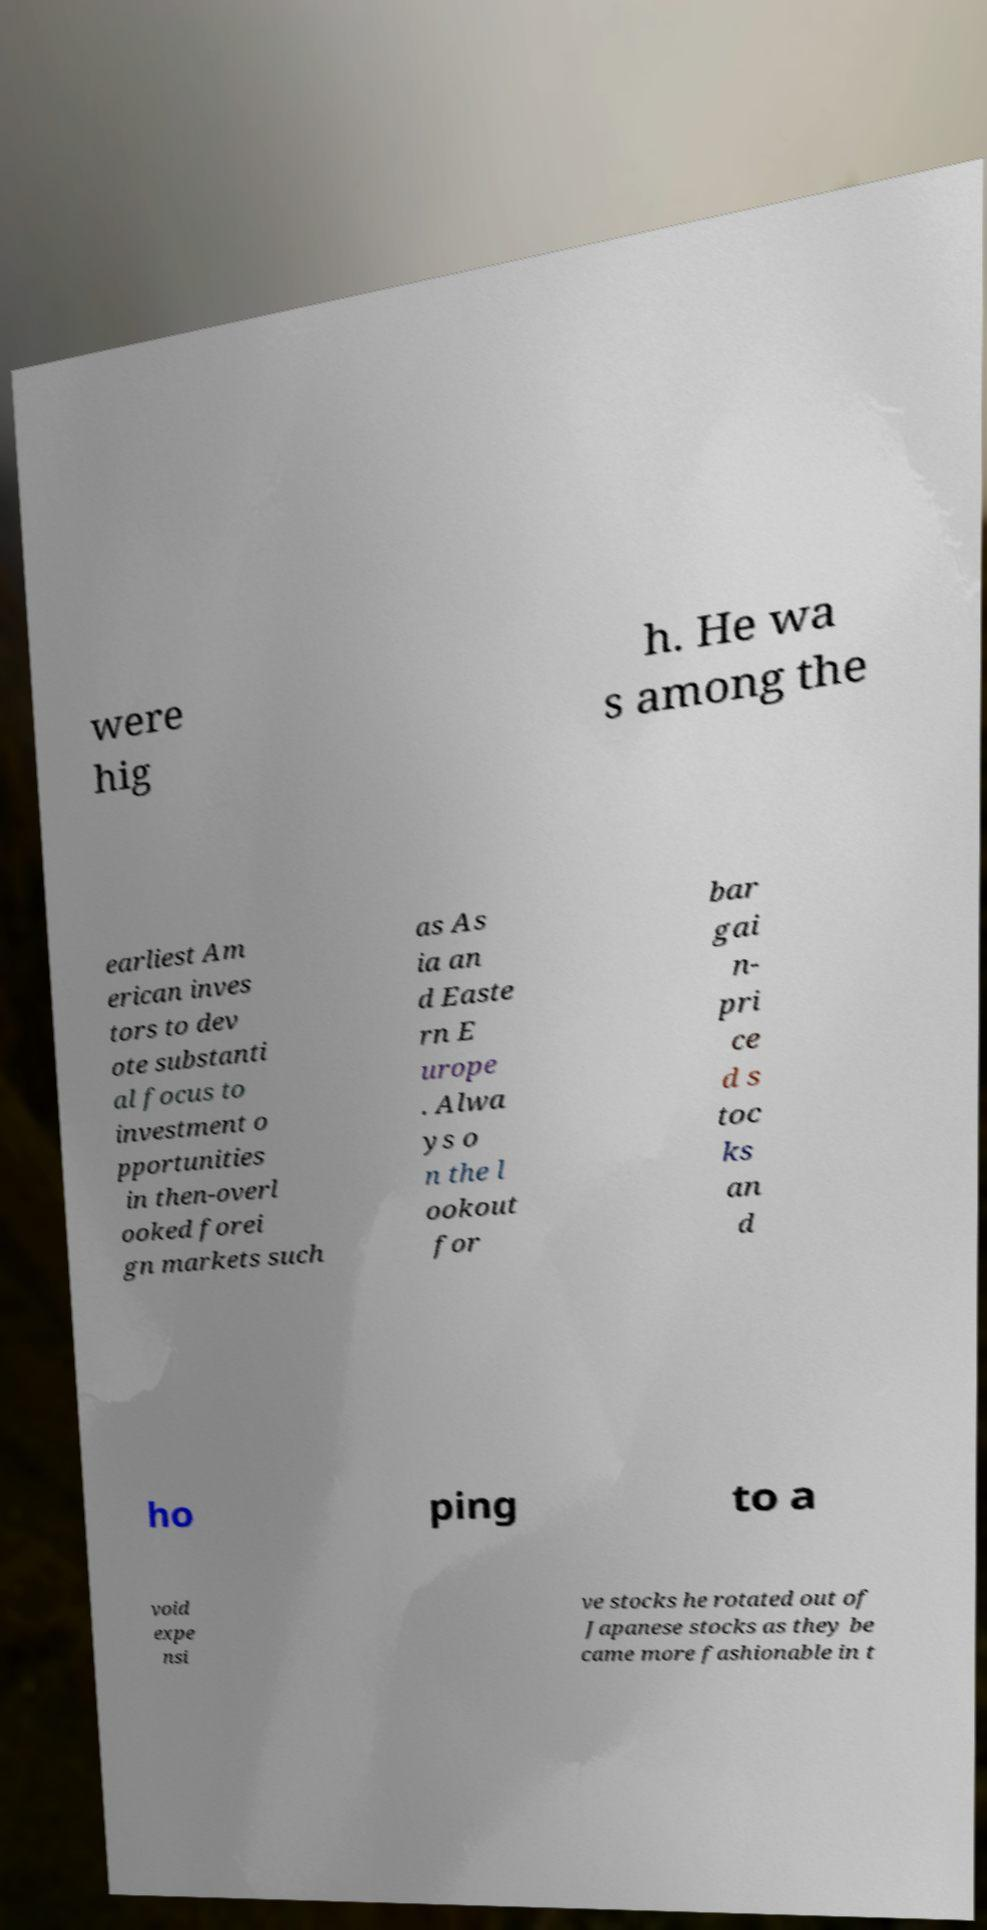Could you assist in decoding the text presented in this image and type it out clearly? were hig h. He wa s among the earliest Am erican inves tors to dev ote substanti al focus to investment o pportunities in then-overl ooked forei gn markets such as As ia an d Easte rn E urope . Alwa ys o n the l ookout for bar gai n- pri ce d s toc ks an d ho ping to a void expe nsi ve stocks he rotated out of Japanese stocks as they be came more fashionable in t 